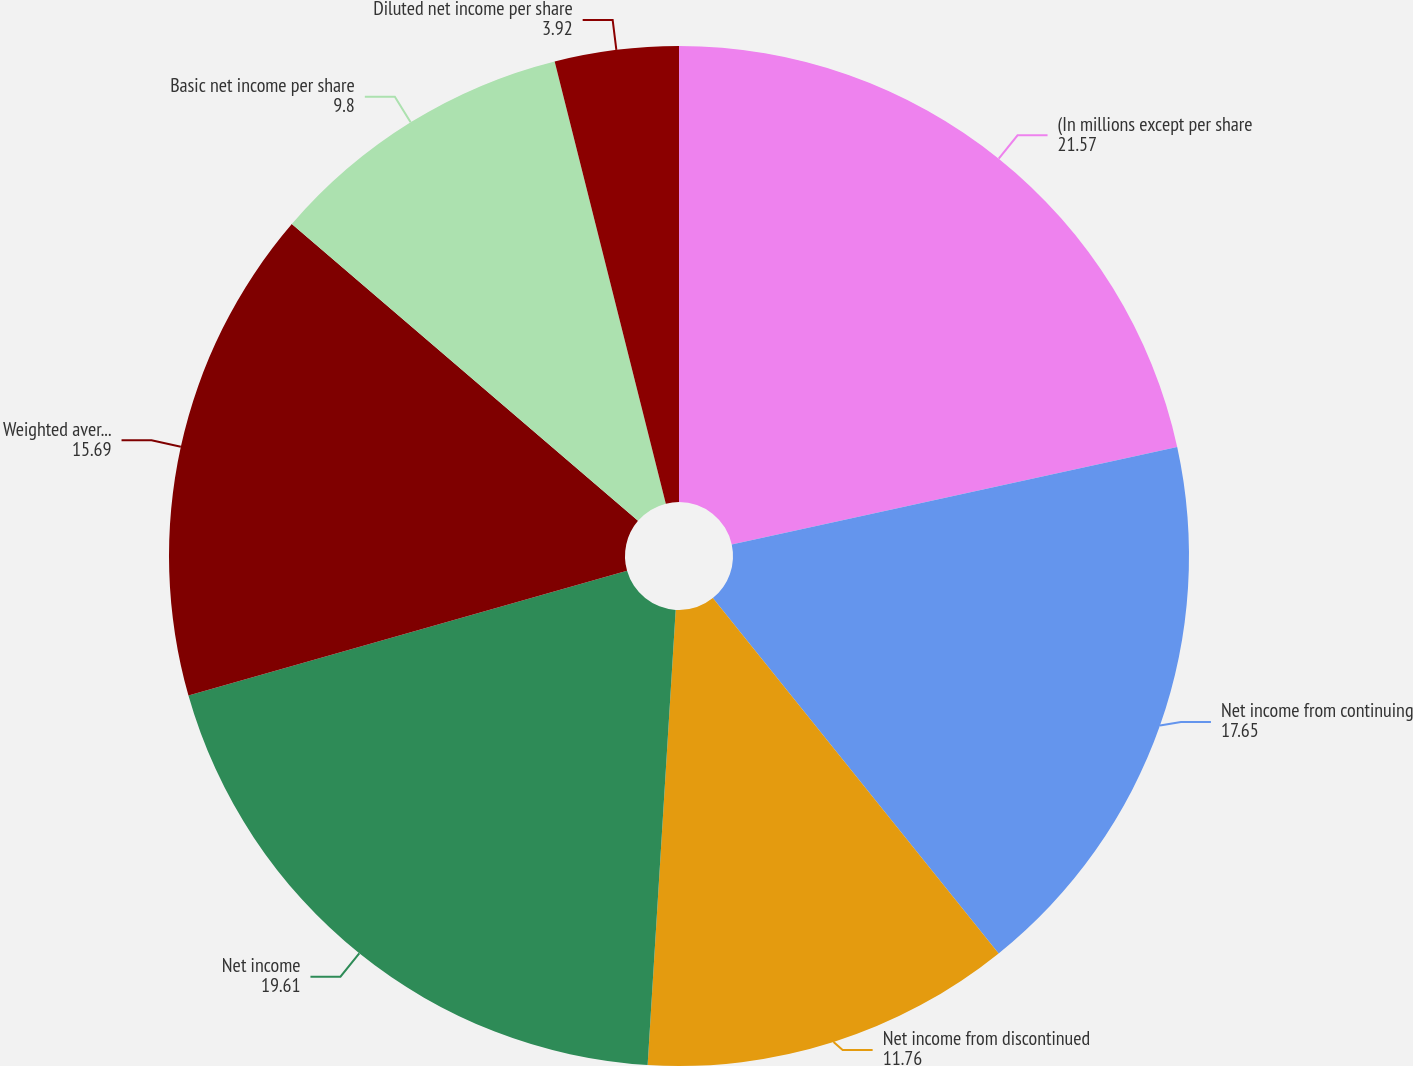Convert chart to OTSL. <chart><loc_0><loc_0><loc_500><loc_500><pie_chart><fcel>(In millions except per share<fcel>Net income from continuing<fcel>Net income from discontinued<fcel>Net income<fcel>Weighted average common shares<fcel>Basic net income per share<fcel>Diluted net income per share<nl><fcel>21.57%<fcel>17.65%<fcel>11.76%<fcel>19.61%<fcel>15.69%<fcel>9.8%<fcel>3.92%<nl></chart> 